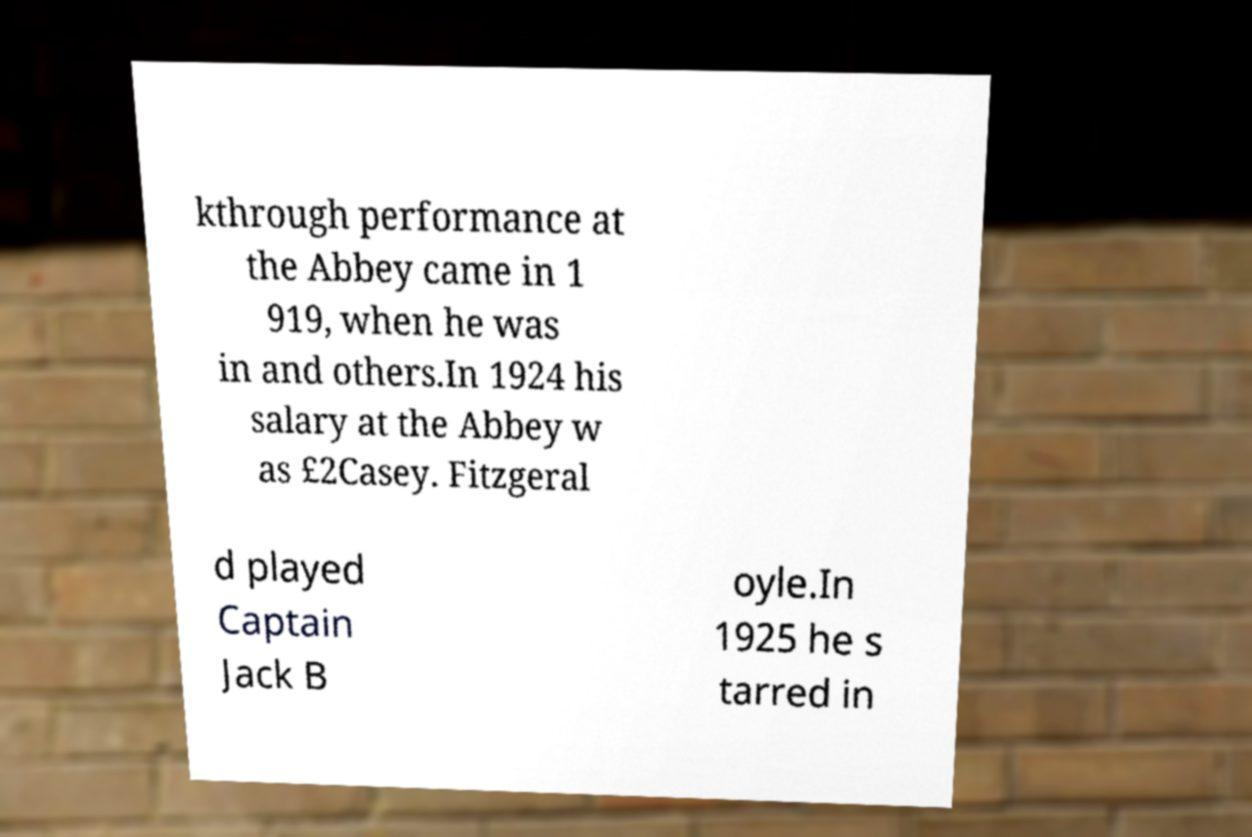What messages or text are displayed in this image? I need them in a readable, typed format. kthrough performance at the Abbey came in 1 919, when he was in and others.In 1924 his salary at the Abbey w as £2Casey. Fitzgeral d played Captain Jack B oyle.In 1925 he s tarred in 